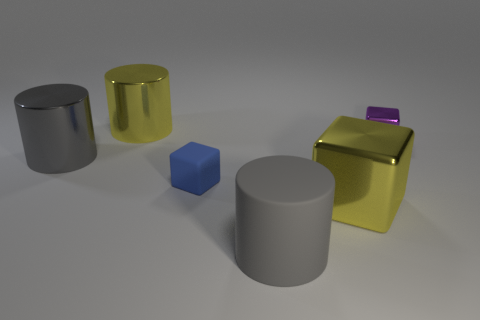Are there any other things that are the same color as the big rubber cylinder?
Give a very brief answer. Yes. What number of tiny blue things are there?
Provide a short and direct response. 1. What is the shape of the large object that is both right of the large yellow cylinder and behind the large gray matte object?
Your answer should be very brief. Cube. There is a small thing in front of the big metallic cylinder that is in front of the big yellow metallic thing that is to the left of the tiny blue cube; what is its shape?
Your answer should be compact. Cube. The cube that is both to the right of the tiny blue cube and in front of the purple object is made of what material?
Offer a very short reply. Metal. How many yellow things have the same size as the yellow cube?
Provide a short and direct response. 1. How many metallic objects are either cyan cylinders or gray cylinders?
Give a very brief answer. 1. What is the tiny blue thing made of?
Your answer should be very brief. Rubber. How many large things are to the left of the yellow cylinder?
Give a very brief answer. 1. Is the large gray cylinder that is to the right of the small matte thing made of the same material as the tiny purple thing?
Offer a terse response. No. 